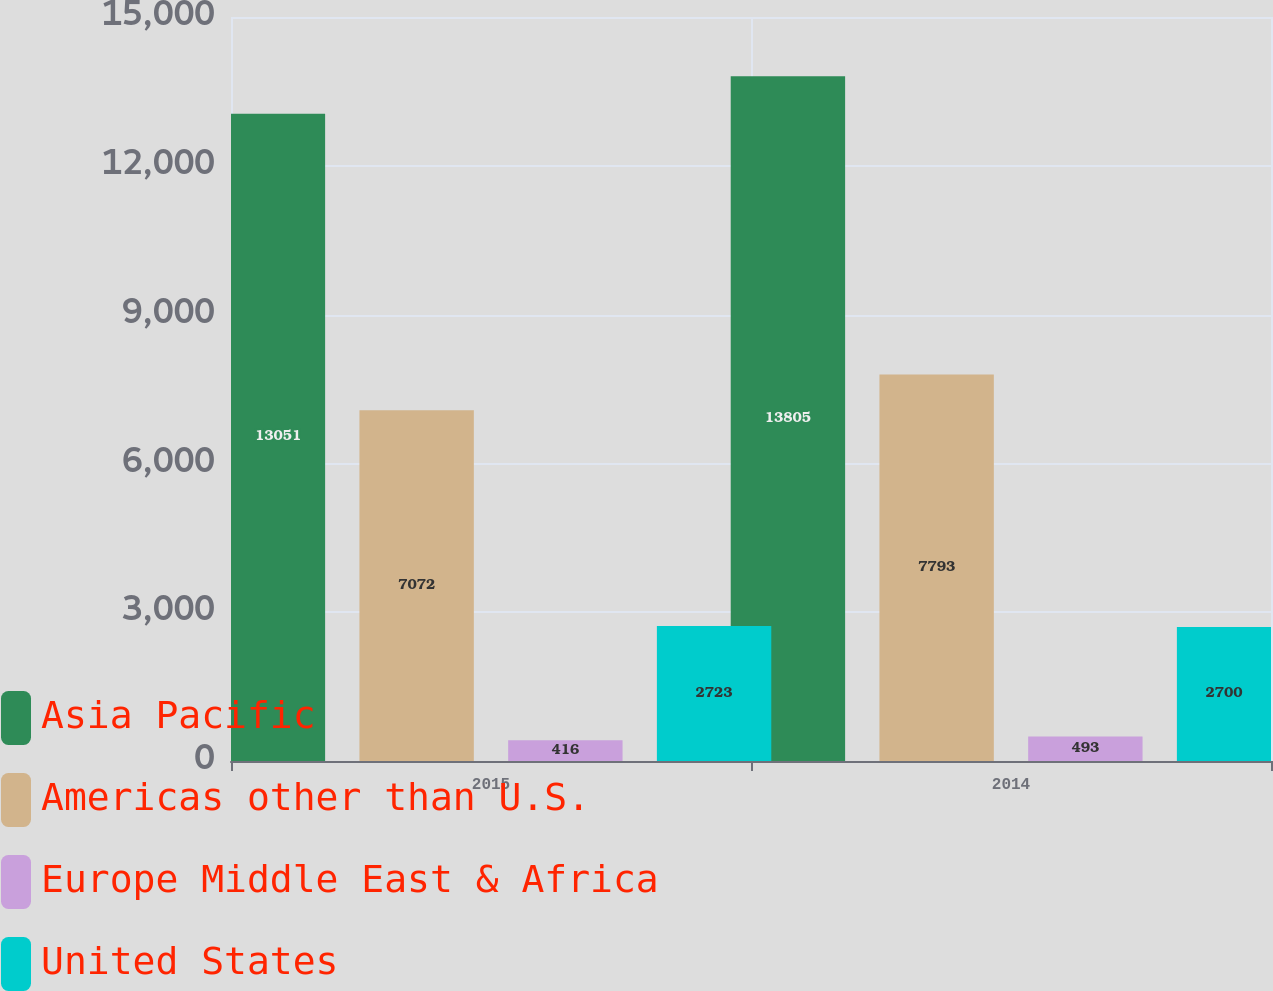<chart> <loc_0><loc_0><loc_500><loc_500><stacked_bar_chart><ecel><fcel>2015<fcel>2014<nl><fcel>Asia Pacific<fcel>13051<fcel>13805<nl><fcel>Americas other than U.S.<fcel>7072<fcel>7793<nl><fcel>Europe Middle East & Africa<fcel>416<fcel>493<nl><fcel>United States<fcel>2723<fcel>2700<nl></chart> 